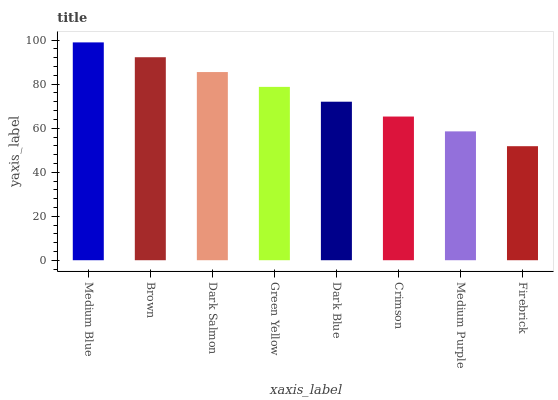Is Firebrick the minimum?
Answer yes or no. Yes. Is Medium Blue the maximum?
Answer yes or no. Yes. Is Brown the minimum?
Answer yes or no. No. Is Brown the maximum?
Answer yes or no. No. Is Medium Blue greater than Brown?
Answer yes or no. Yes. Is Brown less than Medium Blue?
Answer yes or no. Yes. Is Brown greater than Medium Blue?
Answer yes or no. No. Is Medium Blue less than Brown?
Answer yes or no. No. Is Green Yellow the high median?
Answer yes or no. Yes. Is Dark Blue the low median?
Answer yes or no. Yes. Is Crimson the high median?
Answer yes or no. No. Is Firebrick the low median?
Answer yes or no. No. 